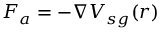Convert formula to latex. <formula><loc_0><loc_0><loc_500><loc_500>F _ { a } = - \nabla V _ { s g } ( r )</formula> 